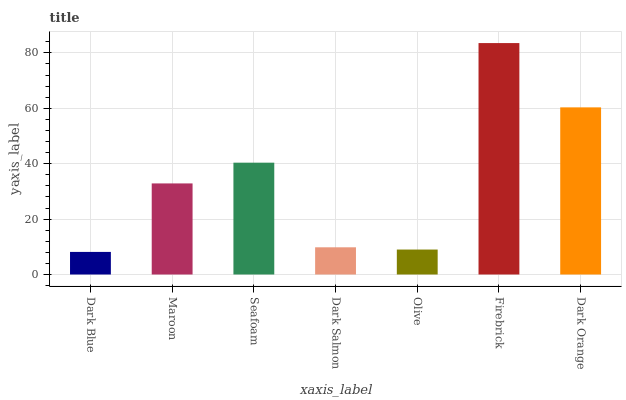Is Dark Blue the minimum?
Answer yes or no. Yes. Is Firebrick the maximum?
Answer yes or no. Yes. Is Maroon the minimum?
Answer yes or no. No. Is Maroon the maximum?
Answer yes or no. No. Is Maroon greater than Dark Blue?
Answer yes or no. Yes. Is Dark Blue less than Maroon?
Answer yes or no. Yes. Is Dark Blue greater than Maroon?
Answer yes or no. No. Is Maroon less than Dark Blue?
Answer yes or no. No. Is Maroon the high median?
Answer yes or no. Yes. Is Maroon the low median?
Answer yes or no. Yes. Is Firebrick the high median?
Answer yes or no. No. Is Olive the low median?
Answer yes or no. No. 